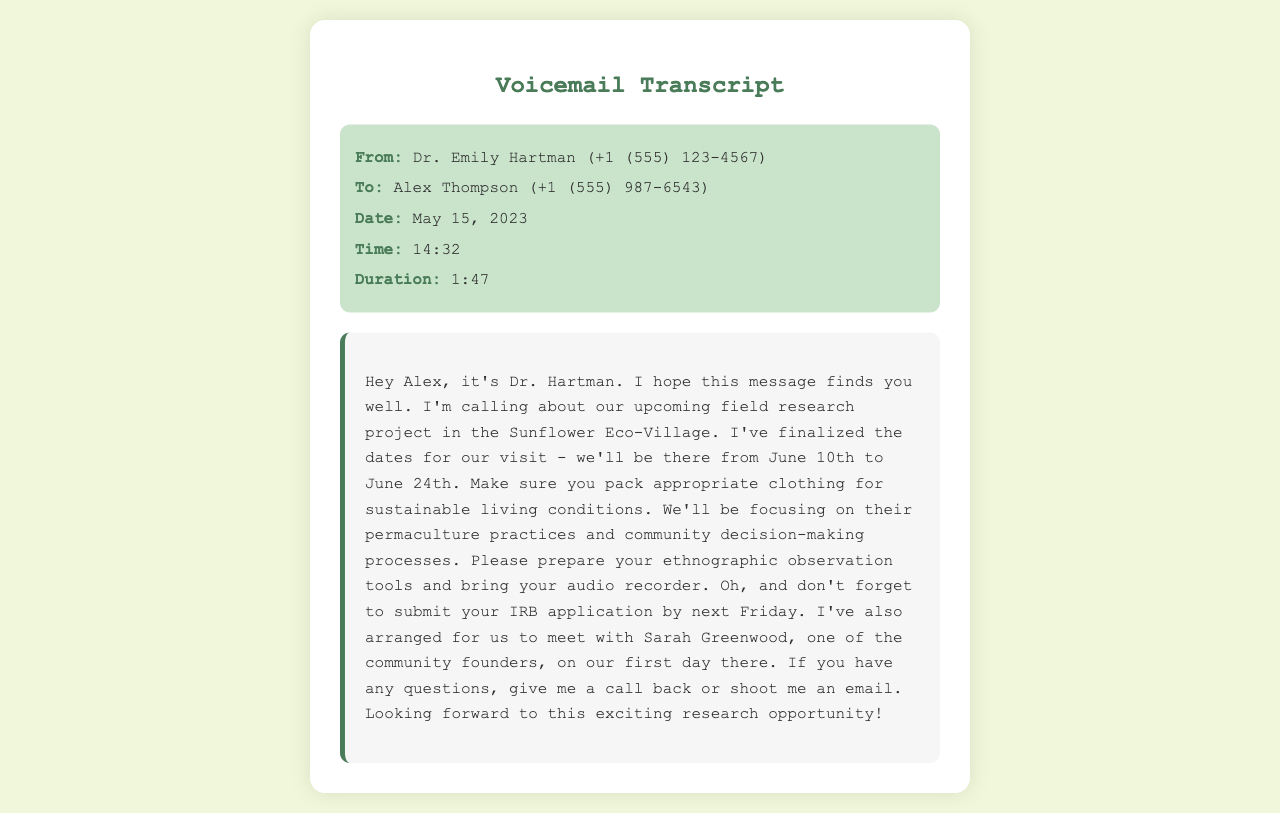What is the name of the professor? The message identifies the professor who called as Dr. Emily Hartman.
Answer: Dr. Emily Hartman What is the recipient's name? The voicemail specifies that the call was made to Alex Thompson.
Answer: Alex Thompson When is the field research project starting? The transcript mentions that the field research project starts on June 10th, 2023.
Answer: June 10th How long will the research project last? The voicemail states that the visit will be from June 10th to June 24th, indicating a duration of 14 days.
Answer: 14 days What should Alex prepare for the trip? Dr. Hartman specifically advises Alex to prepare ethnographic observation tools and an audio recorder.
Answer: Ethnographic observation tools and audio recorder Who is meeting them on their first day? The message mentions meeting with Sarah Greenwood, one of the community founders.
Answer: Sarah Greenwood What is the primary focus of the research? Dr. Hartman states that they will focus on permaculture practices and community decision-making processes.
Answer: Permaculture practices and community decision-making processes What is due next Friday? The professor reminds Alex to submit the IRB application by next Friday.
Answer: IRB application What is the date of the voicemail? The voicemail is dated May 15, 2023.
Answer: May 15, 2023 